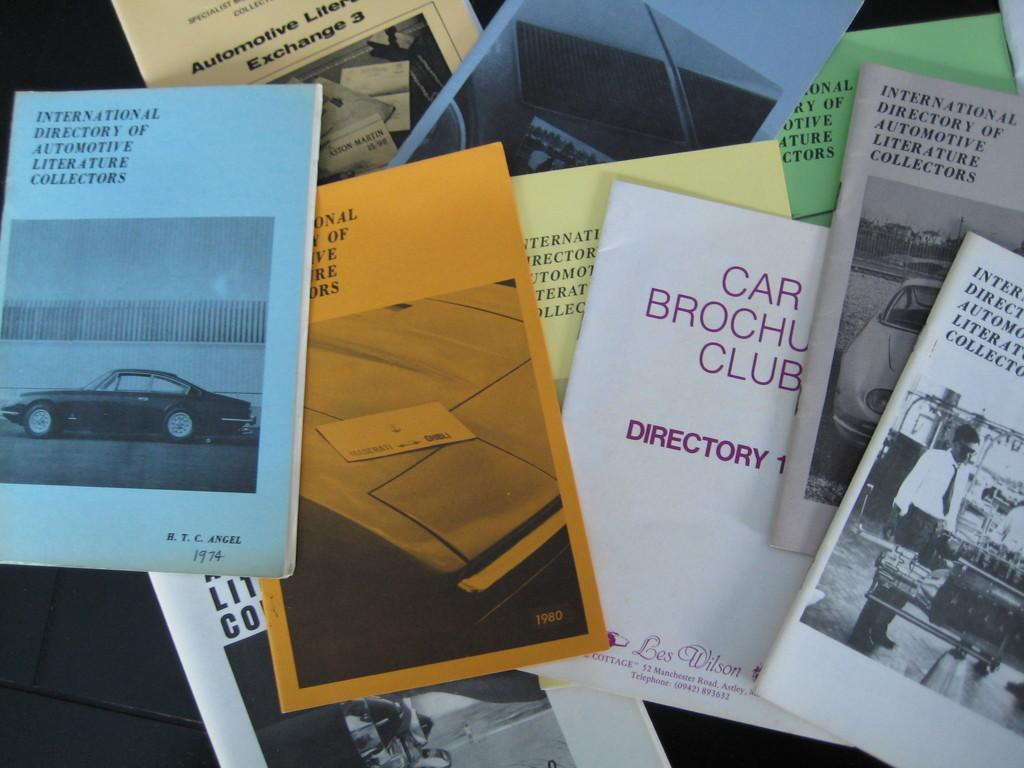<image>
Write a terse but informative summary of the picture. a brochure for the car club directory is shown 